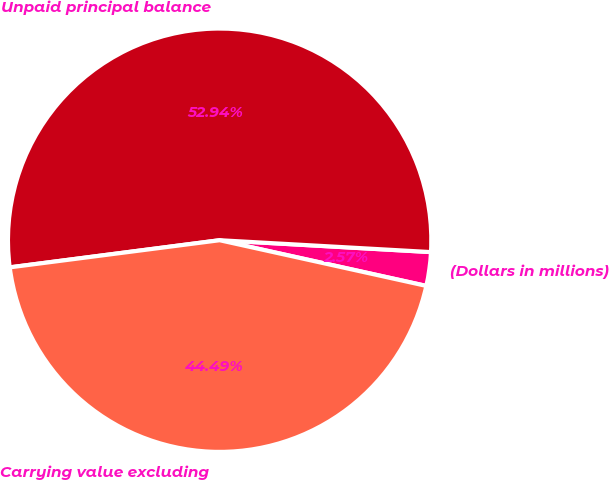<chart> <loc_0><loc_0><loc_500><loc_500><pie_chart><fcel>(Dollars in millions)<fcel>Unpaid principal balance<fcel>Carrying value excluding<nl><fcel>2.57%<fcel>52.94%<fcel>44.49%<nl></chart> 